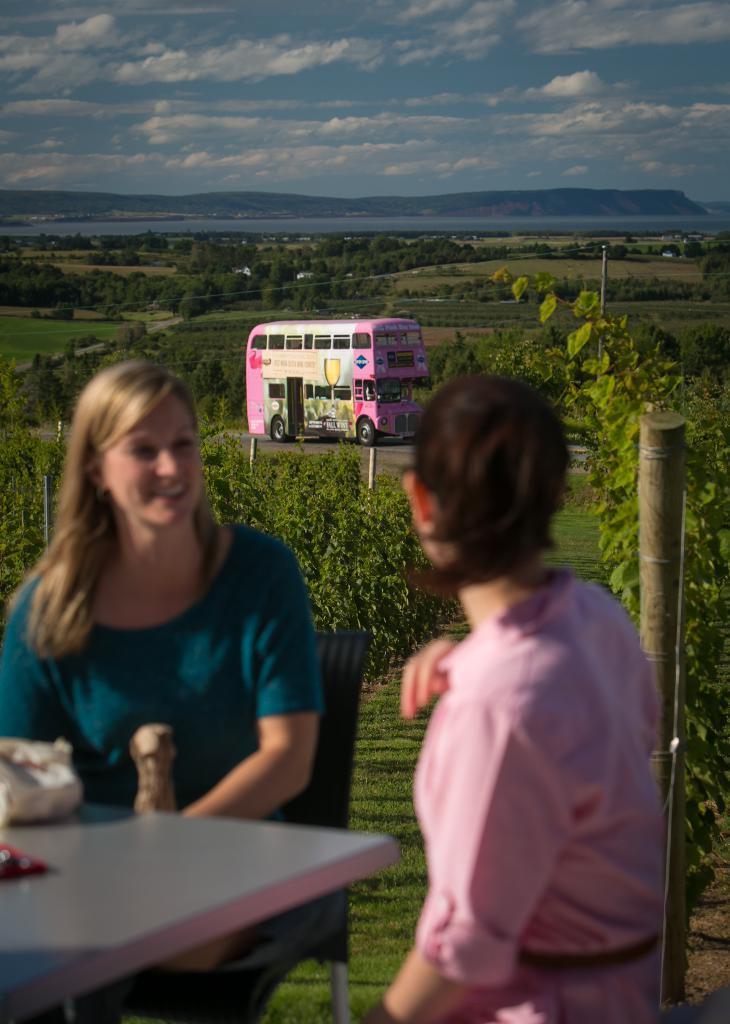How would you summarize this image in a sentence or two? In this picture there are two women who are sitting on the chair. There is a table. There is a bus. There are few trees at the background. The sky is blue and cloudy. 